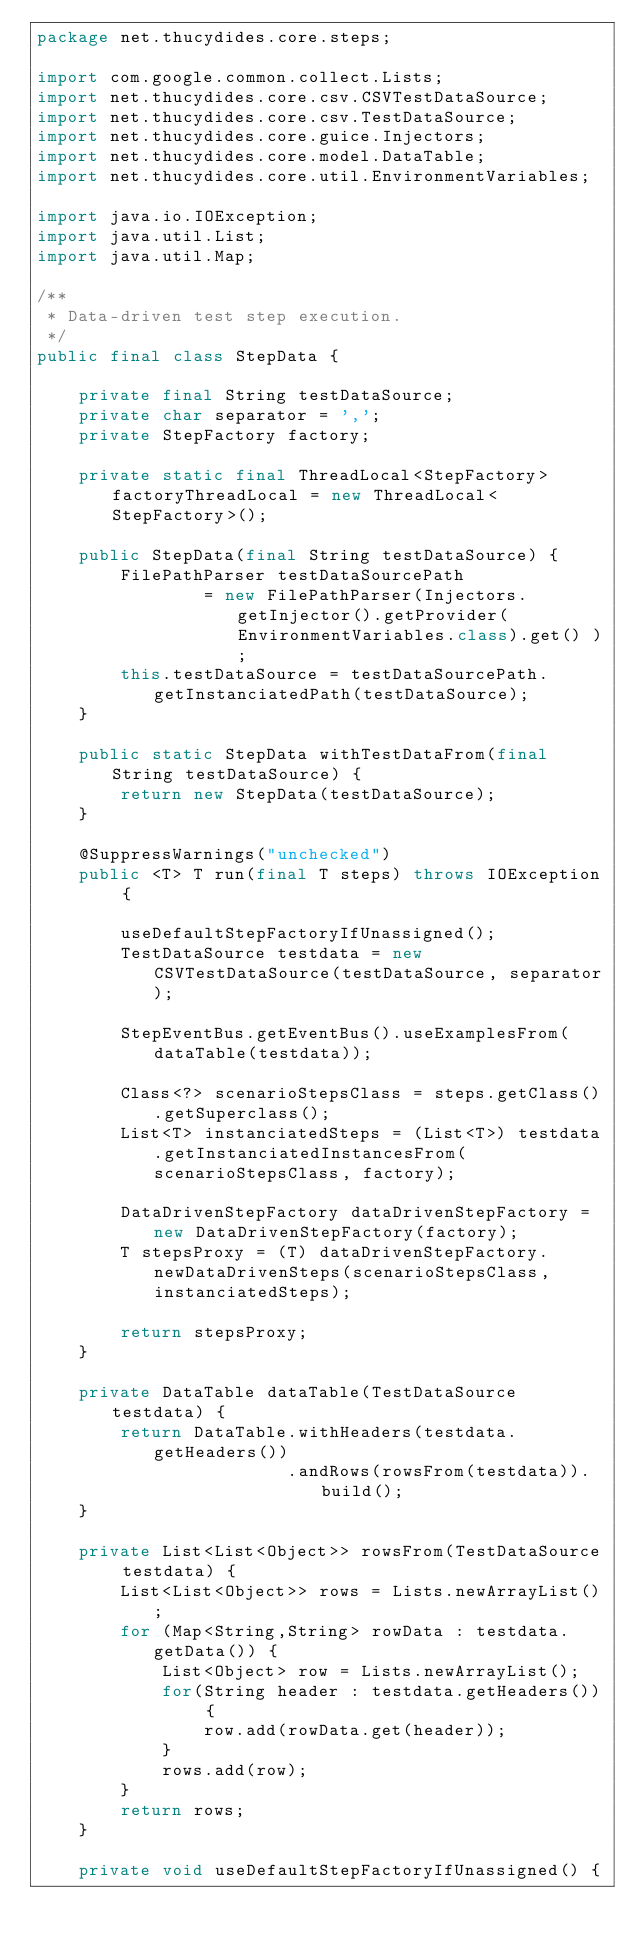Convert code to text. <code><loc_0><loc_0><loc_500><loc_500><_Java_>package net.thucydides.core.steps;

import com.google.common.collect.Lists;
import net.thucydides.core.csv.CSVTestDataSource;
import net.thucydides.core.csv.TestDataSource;
import net.thucydides.core.guice.Injectors;
import net.thucydides.core.model.DataTable;
import net.thucydides.core.util.EnvironmentVariables;

import java.io.IOException;
import java.util.List;
import java.util.Map;

/**
 * Data-driven test step execution.
 */
public final class StepData {

    private final String testDataSource;
    private char separator = ',';
    private StepFactory factory;

    private static final ThreadLocal<StepFactory> factoryThreadLocal = new ThreadLocal<StepFactory>();

    public StepData(final String testDataSource) {
        FilePathParser testDataSourcePath
                = new FilePathParser(Injectors.getInjector().getProvider(EnvironmentVariables.class).get() );
        this.testDataSource = testDataSourcePath.getInstanciatedPath(testDataSource);
    }

    public static StepData withTestDataFrom(final String testDataSource) {
        return new StepData(testDataSource);
    }

    @SuppressWarnings("unchecked")
    public <T> T run(final T steps) throws IOException {

        useDefaultStepFactoryIfUnassigned();
        TestDataSource testdata = new CSVTestDataSource(testDataSource, separator);

        StepEventBus.getEventBus().useExamplesFrom(dataTable(testdata));

        Class<?> scenarioStepsClass = steps.getClass().getSuperclass();
        List<T> instanciatedSteps = (List<T>) testdata.getInstanciatedInstancesFrom(scenarioStepsClass, factory);

        DataDrivenStepFactory dataDrivenStepFactory = new DataDrivenStepFactory(factory);
        T stepsProxy = (T) dataDrivenStepFactory.newDataDrivenSteps(scenarioStepsClass, instanciatedSteps);

        return stepsProxy;
    }

    private DataTable dataTable(TestDataSource testdata) {
        return DataTable.withHeaders(testdata.getHeaders())
                        .andRows(rowsFrom(testdata)).build();
    }

    private List<List<Object>> rowsFrom(TestDataSource testdata) {
        List<List<Object>> rows = Lists.newArrayList();
        for (Map<String,String> rowData : testdata.getData()) {
            List<Object> row = Lists.newArrayList();
            for(String header : testdata.getHeaders()) {
                row.add(rowData.get(header));
            }
            rows.add(row);
        }
        return rows;
    }

    private void useDefaultStepFactoryIfUnassigned() {</code> 